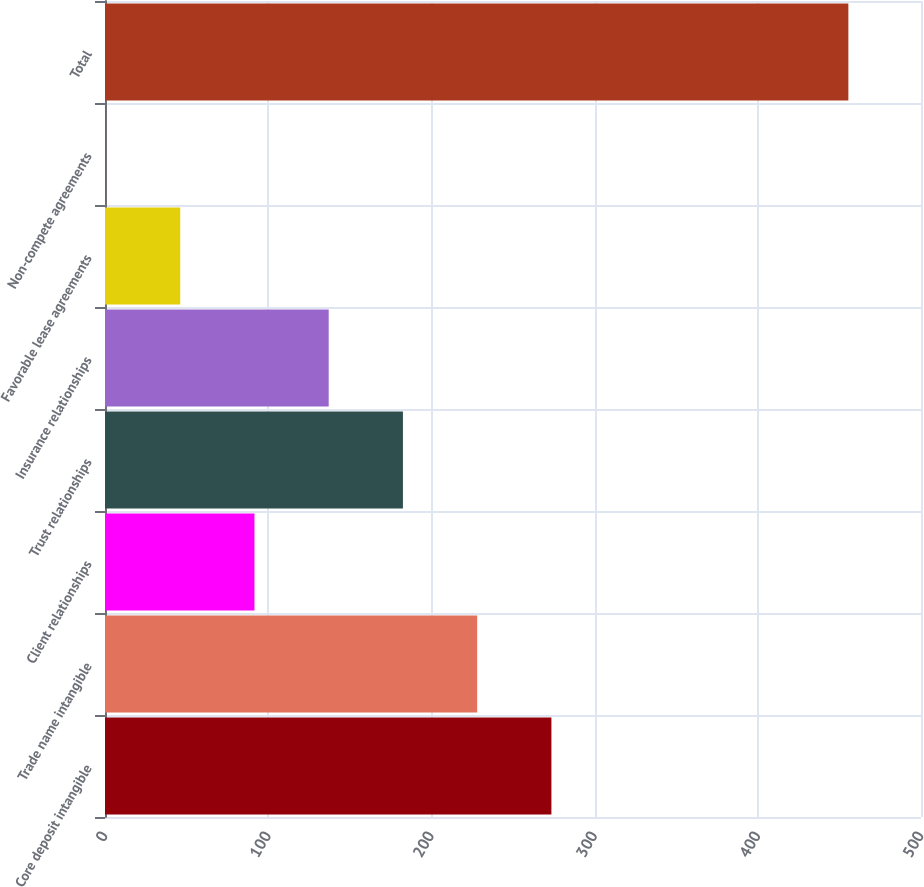Convert chart to OTSL. <chart><loc_0><loc_0><loc_500><loc_500><bar_chart><fcel>Core deposit intangible<fcel>Trade name intangible<fcel>Client relationships<fcel>Trust relationships<fcel>Insurance relationships<fcel>Favorable lease agreements<fcel>Non-compete agreements<fcel>Total<nl><fcel>273.54<fcel>228.05<fcel>91.58<fcel>182.56<fcel>137.07<fcel>46.09<fcel>0.6<fcel>455.5<nl></chart> 